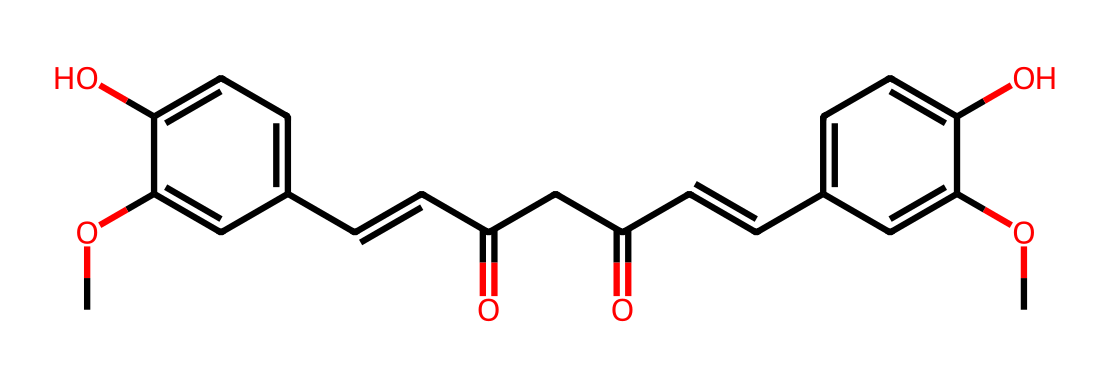what is the molecular formula of curcumin? To find the molecular formula from the SMILES representation, we need to identify the different atoms represented in the structure. Counting the carbon (C), hydrogen (H), and oxygen (O) atoms from the SMILES notation leads to the formula C21H20O6.
Answer: C21H20O6 how many hydroxyl (–OH) groups are present in curcumin? By examining the chemical structure, there are two hydroxyl groups (–OH) indicated in the SMILES notation at specific positions in the aromatic rings.
Answer: 2 what is the primary functional group in curcumin? The primary functional group in curcumin can be identified by looking at the freestanding –OCH3 (methoxy) and the –OH (hydroxyl) groups in the structure. Both suggest that phenols are prominent, but a focused observation shows that curcumin is a phenolic compound mainly due to these groups.
Answer: phenol which elements are present in curcumin? Assessing the SMILES representation, we can identify three elements: carbon (C), hydrogen (H), and oxygen (O). These elements are crucial in building the overall structure of curcumin.
Answer: carbon, hydrogen, oxygen how many rings are present in the structure of curcumin? In the chemical structure, there are two distinct benzene rings that can be visualized in the SMILES notation, showcasing the aromatic nature of curcumin. Thus, the total number of rings is two.
Answer: 2 what type of aromatic compound does curcumin belong to? Looking at the structure, curcumin contains multiple conjugated double bonds and hydroxyl groups, which means it is classified as an aromatic polyphenol. This classification arises from its structural characteristics.
Answer: aromatic polyphenol 